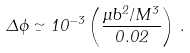<formula> <loc_0><loc_0><loc_500><loc_500>\Delta \phi \simeq 1 0 ^ { - 3 } \left ( \frac { \mu b ^ { 2 } / M ^ { 3 } } { 0 . 0 2 } \right ) \, .</formula> 